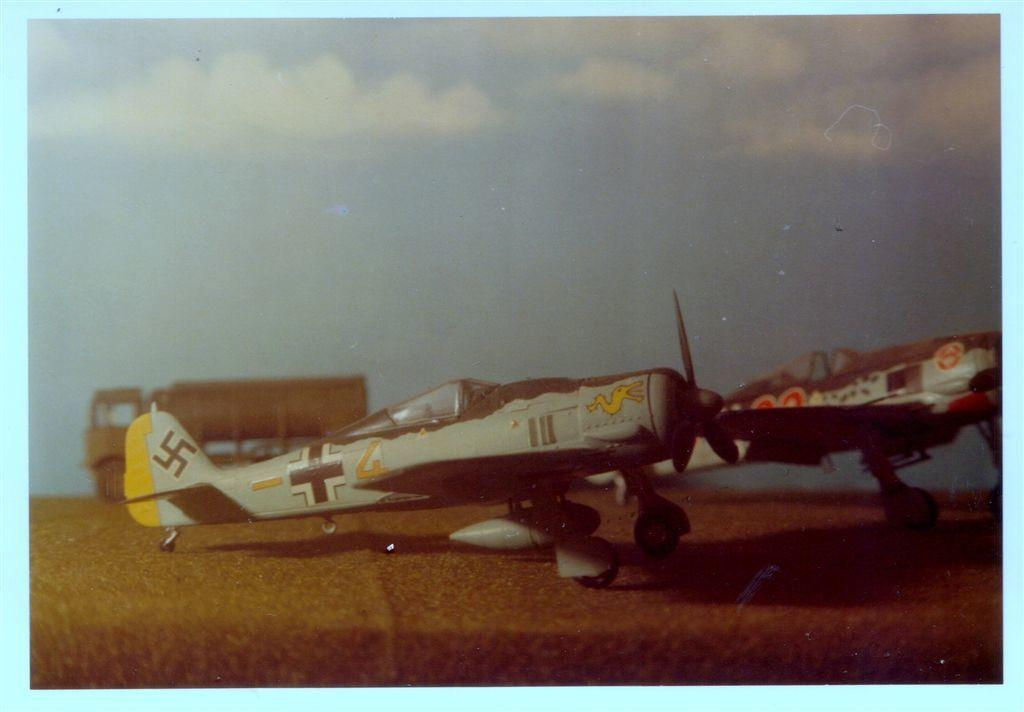What is the main subject of the image? There is a painting in the image. What is depicted in the painting? The painting contains an aircraft. Can you describe the scene in the painting? There is a truck behind the aircraft in the painting. What type of flame can be seen coming from the aircraft in the image? There is no flame present in the image; the painting depicts an aircraft and a truck. 